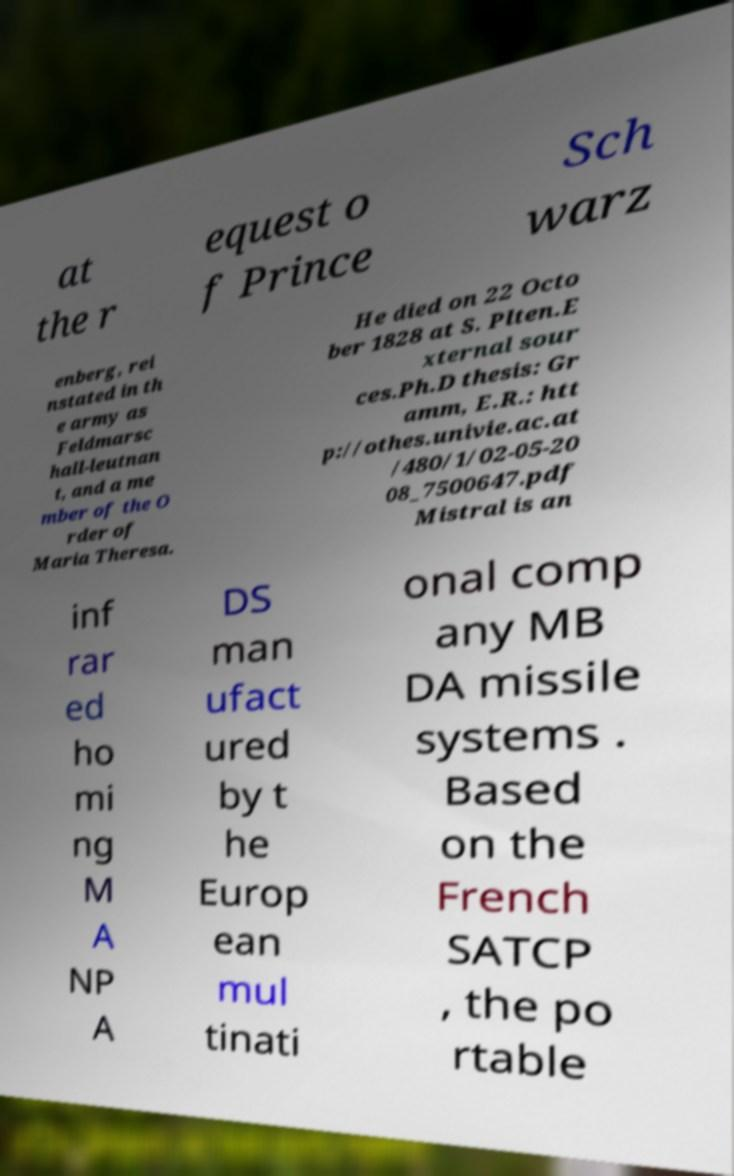I need the written content from this picture converted into text. Can you do that? at the r equest o f Prince Sch warz enberg, rei nstated in th e army as Feldmarsc hall-leutnan t, and a me mber of the O rder of Maria Theresa. He died on 22 Octo ber 1828 at S. Plten.E xternal sour ces.Ph.D thesis: Gr amm, E.R.: htt p://othes.univie.ac.at /480/1/02-05-20 08_7500647.pdf Mistral is an inf rar ed ho mi ng M A NP A DS man ufact ured by t he Europ ean mul tinati onal comp any MB DA missile systems . Based on the French SATCP , the po rtable 